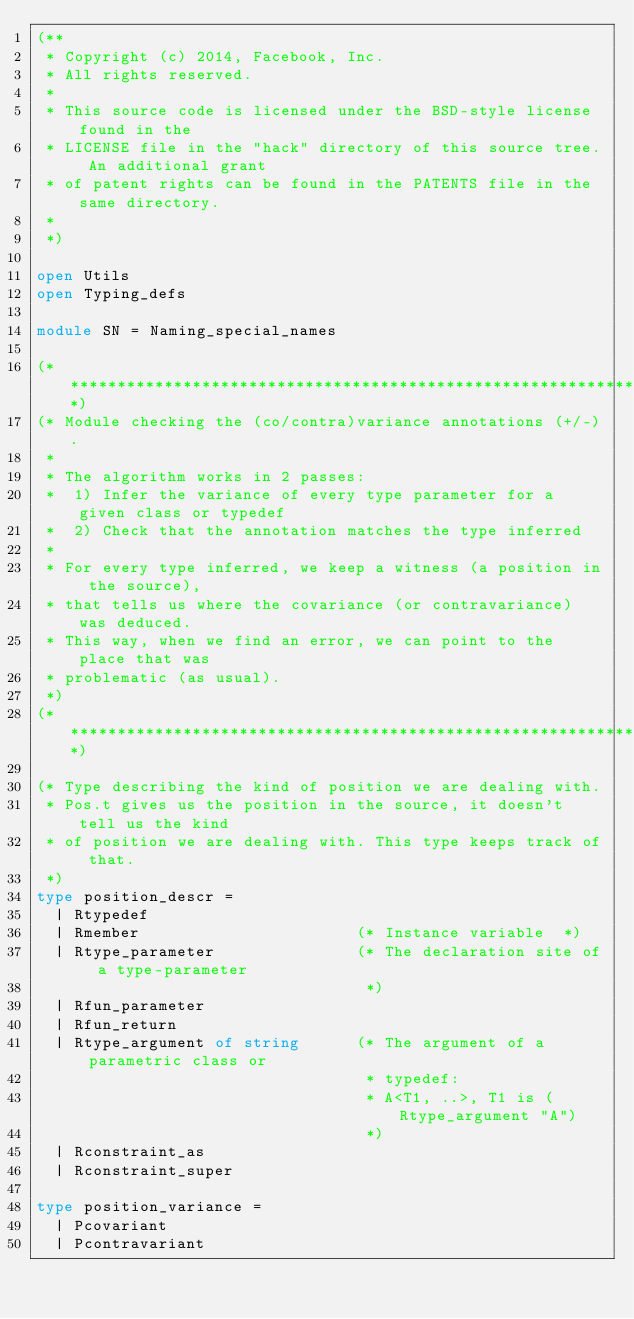Convert code to text. <code><loc_0><loc_0><loc_500><loc_500><_OCaml_>(**
 * Copyright (c) 2014, Facebook, Inc.
 * All rights reserved.
 *
 * This source code is licensed under the BSD-style license found in the
 * LICENSE file in the "hack" directory of this source tree. An additional grant
 * of patent rights can be found in the PATENTS file in the same directory.
 *
 *)

open Utils
open Typing_defs

module SN = Naming_special_names

(*****************************************************************************)
(* Module checking the (co/contra)variance annotations (+/-).
 *
 * The algorithm works in 2 passes:
 *  1) Infer the variance of every type parameter for a given class or typedef
 *  2) Check that the annotation matches the type inferred
 *
 * For every type inferred, we keep a witness (a position in the source),
 * that tells us where the covariance (or contravariance) was deduced.
 * This way, when we find an error, we can point to the place that was
 * problematic (as usual).
 *)
(*****************************************************************************)

(* Type describing the kind of position we are dealing with.
 * Pos.t gives us the position in the source, it doesn't tell us the kind
 * of position we are dealing with. This type keeps track of that.
 *)
type position_descr =
  | Rtypedef
  | Rmember                       (* Instance variable  *)
  | Rtype_parameter               (* The declaration site of a type-parameter
                                   *)
  | Rfun_parameter
  | Rfun_return
  | Rtype_argument of string      (* The argument of a parametric class or
                                   * typedef:
                                   * A<T1, ..>, T1 is (Rtype_argument "A")
                                   *)
  | Rconstraint_as
  | Rconstraint_super

type position_variance =
  | Pcovariant
  | Pcontravariant</code> 